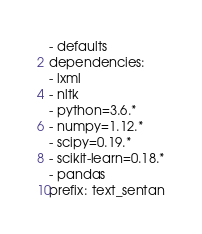<code> <loc_0><loc_0><loc_500><loc_500><_YAML_>- defaults
dependencies:
- lxml
- nltk
- python=3.6.*
- numpy=1.12.*
- scipy=0.19.*
- scikit-learn=0.18.*
- pandas
prefix: text_sentan
</code> 